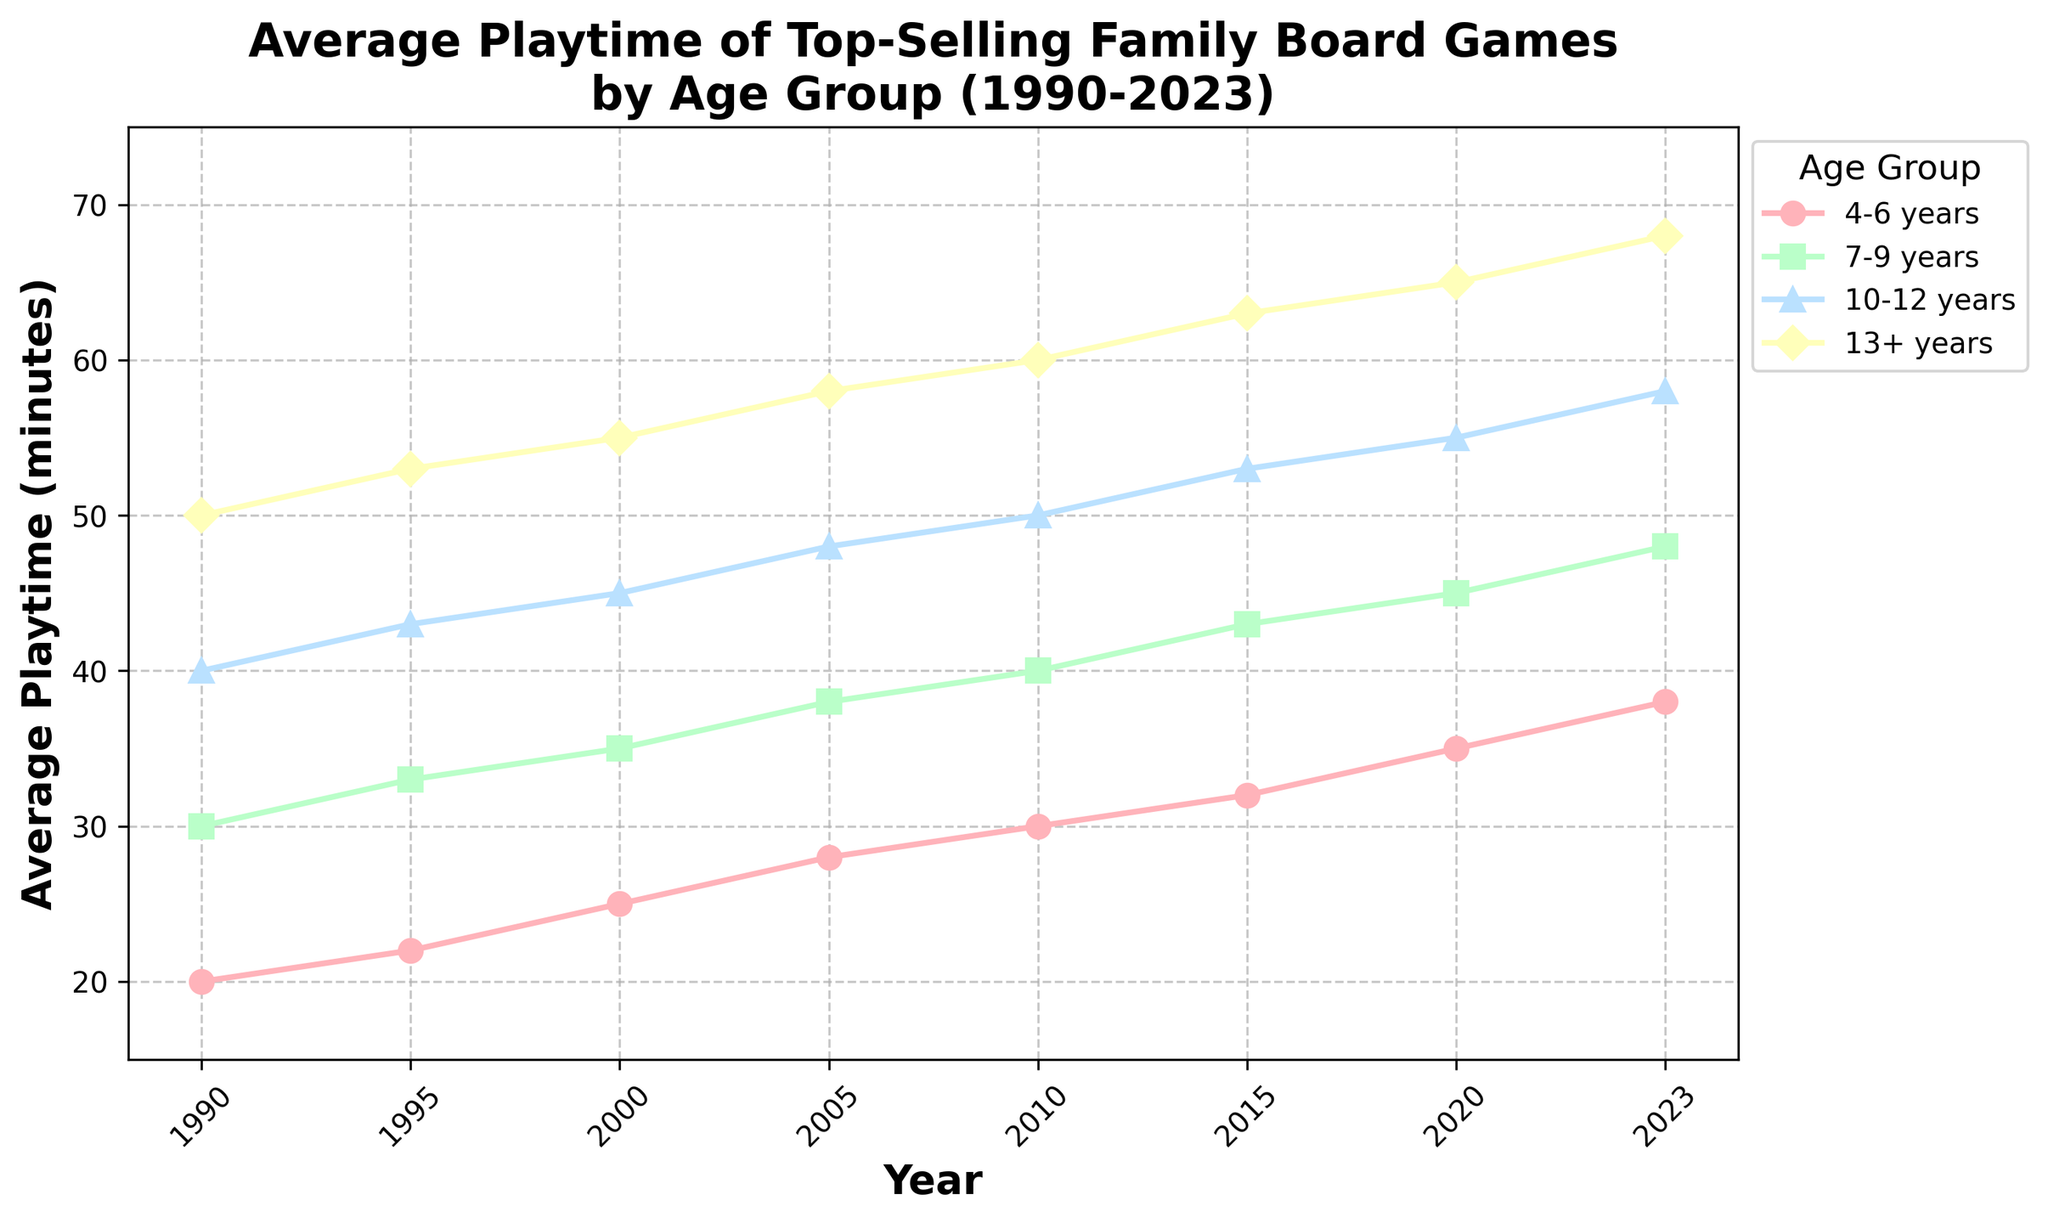What's the average playtime for the 4-6 years age group across all years? To find the average playtime, sum the playtime values for each year from 1990 to 2023 for the 4-6 years age group and then divide by the number of years. (20 + 22 + 25 + 28 + 30 + 32 + 35 + 38) / 8 = 230 / 8 = 28.75
Answer: 28.75 Which age group had the highest average playtime in 2023? To find which age group had the highest average playtime in 2023, look at the playtime values for each age group in 2023. The values are 38 (4-6 years), 48 (7-9 years), 58 (10-12 years), and 68 (13+ years). The highest value is 68, which corresponds to the 13+ years age group.
Answer: 13+ years How much did the average playtime for the 7-9 years age group increase from 1990 to 2023? To find the increase in playtime for the 7-9 years age group from 1990 to 2023, subtract the playtime in 1990 from that in 2023. 48 (2023) - 30 (1990) = 18.
Answer: 18 Which year(s) did the 4-6 years age group have a greater playtime than the 7-9 years age group? To find the years where the 4-6 years age group had a greater playtime than the 7-9 years age group, compare the playtime values for each year. The 4-6 years group never had a greater playtime than the 7-9 years group in any year from 1990 to 2023.
Answer: None What is the total playtime across all age groups in 2015? To find the total playtime across all age groups in 2015, sum the playtime values for each age group. 32 (4-6 years) + 43 (7-9 years) + 53 (10-12 years) + 63 (13+ years) = 32 + 43 + 53 + 63 = 191
Answer: 191 Did the average playtime for the 10-12 years age group ever decline between two consecutive periods? To check if there was any decline, compare the playtime values for consecutive years. The 10-12 years playtime values are consistently increasing: 40, 43, 45, 48, 50, 53, 55, 58. No decline is observed.
Answer: No What is the color and marker shape representing the 10-12 years age group? According to the legend, the 10-12 years age group is represented by the third visual line. The color is light blue and the marker shape is a triangle (^)
Answer: Light blue and triangle Considering the slope of the trend lines, which age group appears to show the steepest increase in average playtime over the years? To determine which age group shows the steepest increase, visually inspect the slopes of the trend lines. The age group 13+ years shows the steepest increase from 50 in 1990 to 68 in 2023.
Answer: 13+ years How does the trend of average playtime for family board games in the 4-6 years age group compare to the 13+ age group from 1990 to 2023? The trend lines for both age groups show a consistent increase over the years. However, the increase is steeper for the 13+ age group. From 1990 to 2023, the 4-6 years group increased from 20 to 38 (an 18-minute increase) while the 13+ years group increased from 50 to 68 (a 28-minute increase)
Answer: The 13+ years group has a steeper increase than the 4-6 years group 